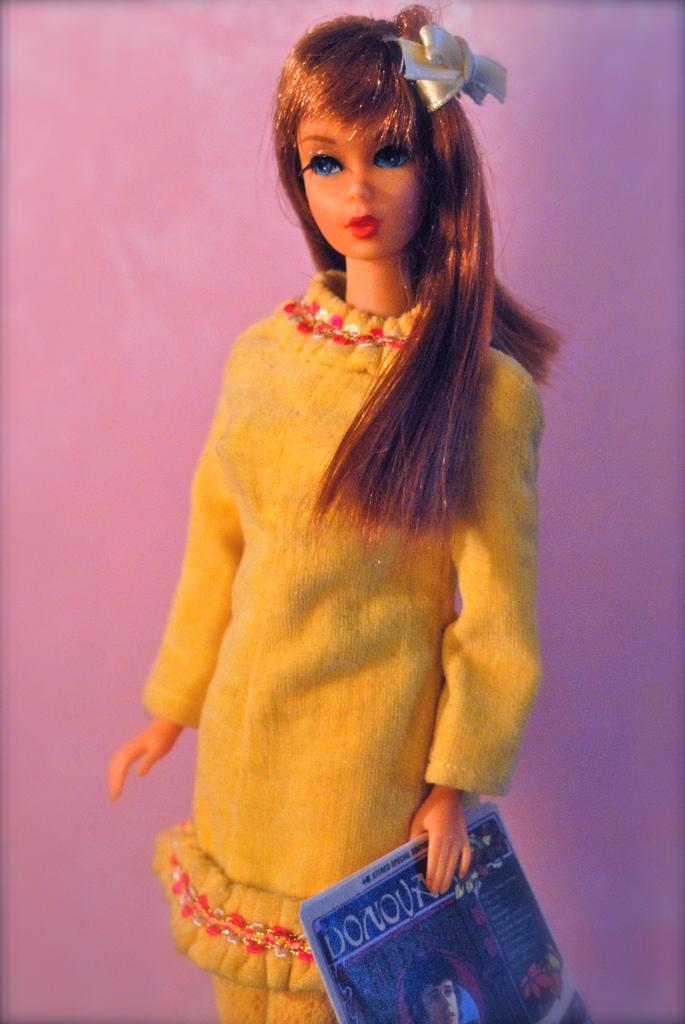What is the main subject in the image? There is a doll in the image. What is the doll holding in the image? The doll is holding an object. What color is the background of the image? The background of the image is pink. What type of sense does the doll have in the image? The image does not provide information about the doll's senses, so we cannot determine what type of sense it has. 